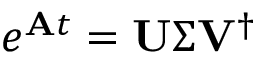Convert formula to latex. <formula><loc_0><loc_0><loc_500><loc_500>e ^ { A t } = U \Sigma V ^ { \dag }</formula> 